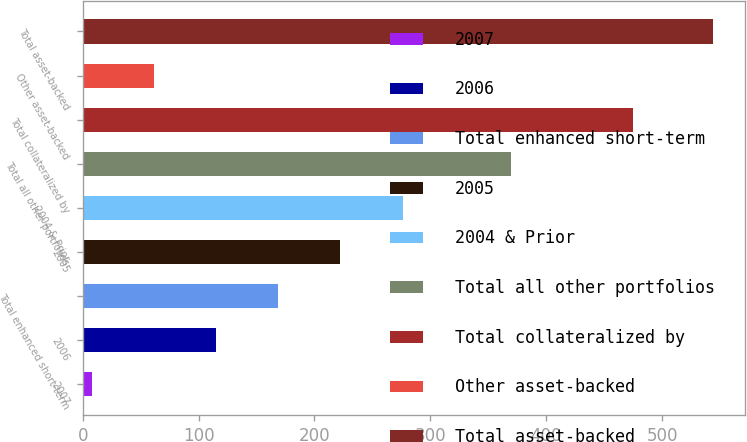Convert chart. <chart><loc_0><loc_0><loc_500><loc_500><bar_chart><fcel>2007<fcel>2006<fcel>Total enhanced short-term<fcel>2005<fcel>2004 & Prior<fcel>Total all other portfolios<fcel>Total collateralized by<fcel>Other asset-backed<fcel>Total asset-backed<nl><fcel>8<fcel>115.2<fcel>168.8<fcel>222.4<fcel>276<fcel>370<fcel>475<fcel>61.6<fcel>544<nl></chart> 